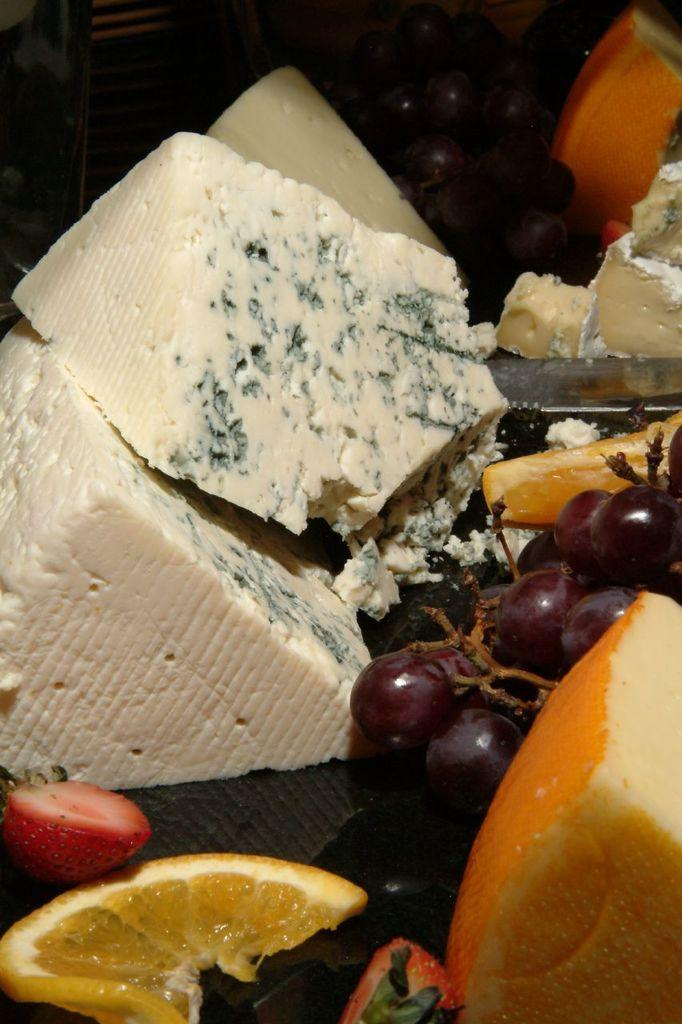What types of items can be seen in the image? There are food items in the image. Can you describe the background of the image? The background of the image is dark. How much salt is present in the image? There is no salt visible in the image, as it only contains food items. What type of learning is taking place in the image? There is no learning activity depicted in the image; it only shows food items. 